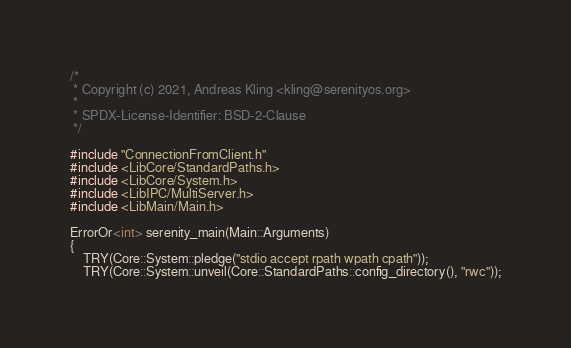<code> <loc_0><loc_0><loc_500><loc_500><_C++_>/*
 * Copyright (c) 2021, Andreas Kling <kling@serenityos.org>
 *
 * SPDX-License-Identifier: BSD-2-Clause
 */

#include "ConnectionFromClient.h"
#include <LibCore/StandardPaths.h>
#include <LibCore/System.h>
#include <LibIPC/MultiServer.h>
#include <LibMain/Main.h>

ErrorOr<int> serenity_main(Main::Arguments)
{
    TRY(Core::System::pledge("stdio accept rpath wpath cpath"));
    TRY(Core::System::unveil(Core::StandardPaths::config_directory(), "rwc"));</code> 